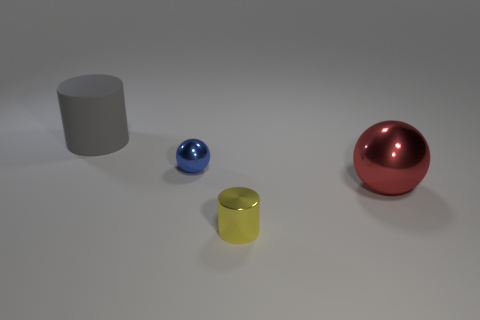Is there any other thing that has the same material as the gray thing?
Your answer should be compact. No. There is a rubber object; what number of spheres are on the left side of it?
Your answer should be very brief. 0. Is there a blue thing that has the same shape as the gray matte thing?
Offer a terse response. No. There is a thing that is the same size as the yellow metal cylinder; what color is it?
Provide a succinct answer. Blue. Are there fewer red metallic things behind the gray rubber cylinder than large cylinders to the left of the blue object?
Your response must be concise. Yes. There is a shiny sphere that is to the right of the yellow metallic cylinder; is it the same size as the small yellow shiny object?
Provide a succinct answer. No. There is a large gray object behind the tiny blue metallic sphere; what is its shape?
Give a very brief answer. Cylinder. Is the number of tiny spheres greater than the number of red matte cylinders?
Ensure brevity in your answer.  Yes. How many things are big things on the right side of the matte cylinder or big things that are to the right of the small blue shiny sphere?
Ensure brevity in your answer.  1. How many shiny balls are in front of the tiny blue shiny thing and to the left of the big shiny object?
Ensure brevity in your answer.  0. 